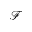Convert formula to latex. <formula><loc_0><loc_0><loc_500><loc_500>\mathcal { F }</formula> 